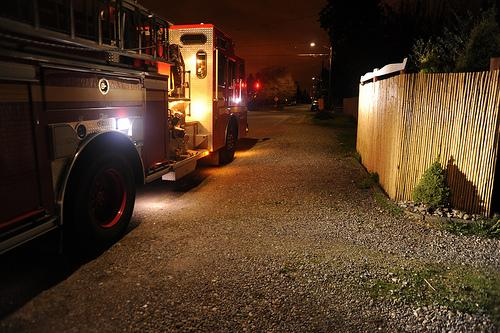Identify the primary object in the image and provide a short description of its surroundings. The main object is a red fire truck on the street, surrounded by a wooden fence, a small green tree, and a red street signal. In a sentence or two, describe the most noticeable elements in the image. A red fire truck with its lights on is parked on the street, beside a wooden fence and a small green tree. Narrate the scene captured in the image, highlighting the color of the main object. A red fire truck stationed on the road beside a tall brown fence, surrounded by various features like a small green tree and a red tire rim. Provide a concise summary of the central vehicle in the picture and the context in which it is depicted. A parked red fire truck on the street, featured alongside other elements such as a wooden fence, a green tree, and a red tire rim. In one sentence, describe the main object in the image and characterize the environment it is in. The image illustrates a red fire truck stationed on the street, amid a wooden fence and a small green tree. Report on the focal point of the image and include relevant details about its location. The focal point of the image is a red fire truck positioned on the street, in proximity to a tall brown fence and a green tree. Write a brief narrative detailing the primary subject of the image and its situation. The scene showcases a red fire truck stationed on the road near a tall wooden fence, with various objects like a green tree and a red street signal in the surroundings. Explain the position and appearance of the prominent vehicle in the context of the image. The fire truck stands on the street in front of a tall brown fence and a green tree, showcasing its red color and bright light. Provide a brief description of the featured vehicle in the image and its situation. A red fire truck is parked on the street with its lights on, surrounded by various objects such as a tree and a fence. Mention the key elements in the scene and describe their characteristics. Red fire truck parked on the street, wooden fence, small green tree, red tire rim, silver gas cap, metal fender, and red street signal. 